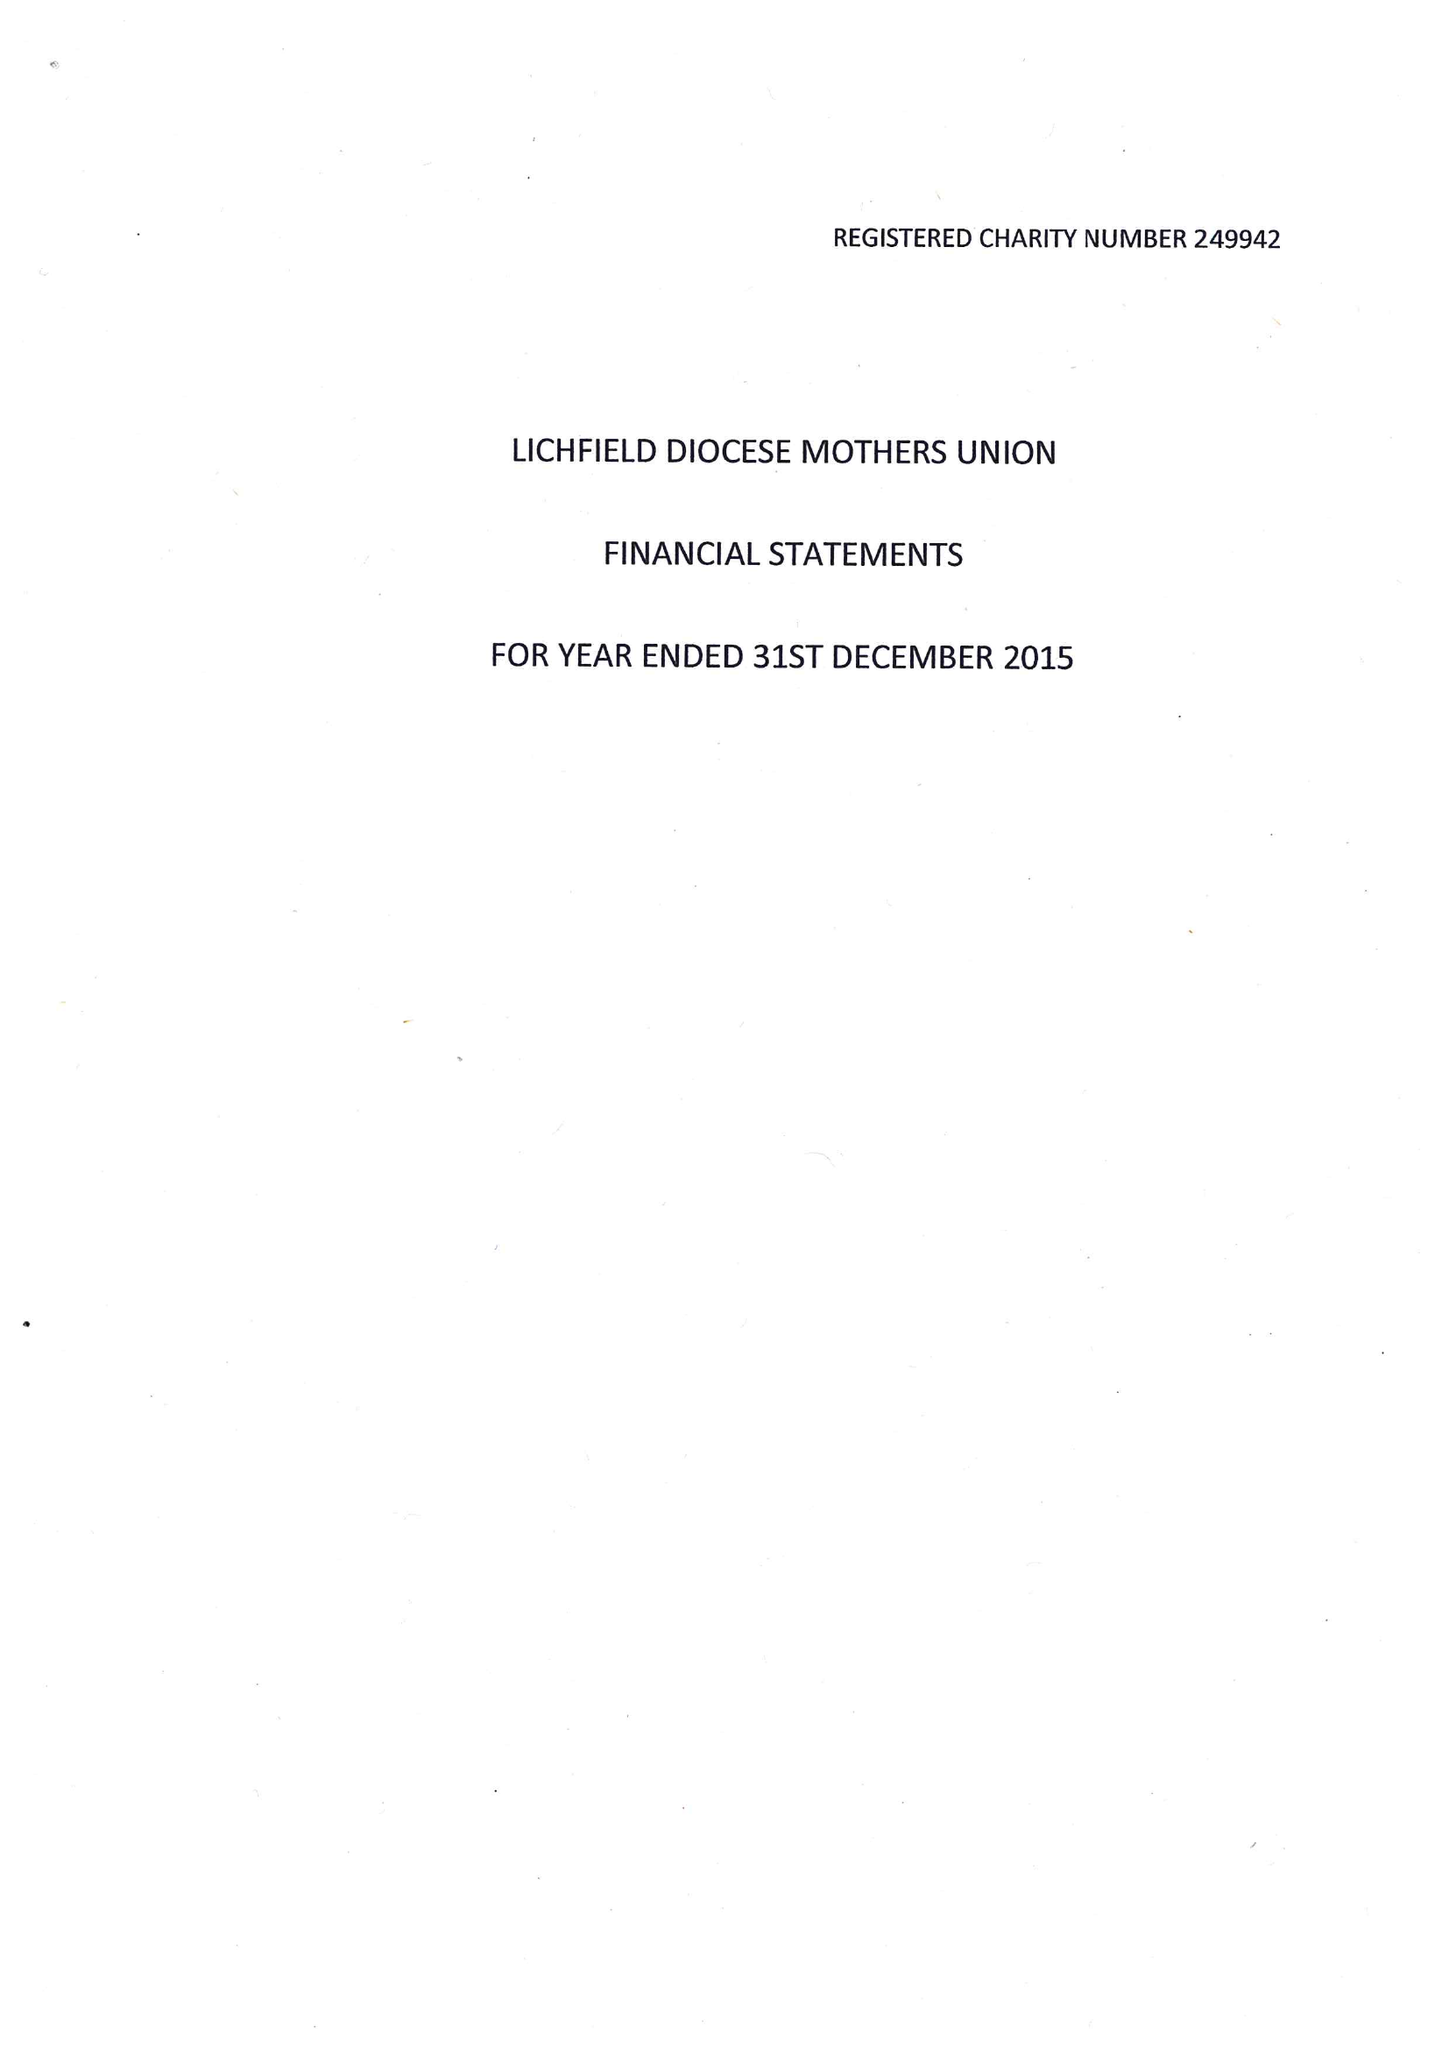What is the value for the spending_annually_in_british_pounds?
Answer the question using a single word or phrase. 98848.00 